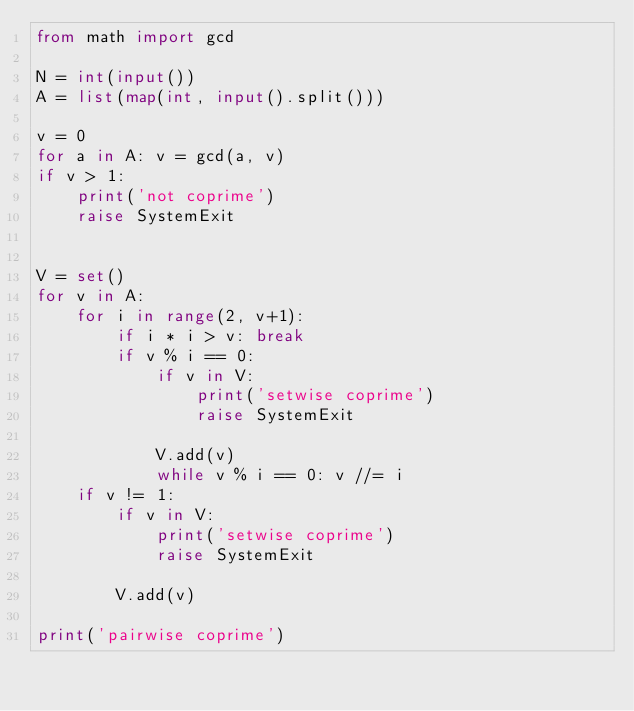Convert code to text. <code><loc_0><loc_0><loc_500><loc_500><_Python_>from math import gcd

N = int(input())
A = list(map(int, input().split()))

v = 0
for a in A: v = gcd(a, v)
if v > 1:
	print('not coprime')
	raise SystemExit


V = set()
for v in A:
	for i in range(2, v+1):
		if i * i > v: break
		if v % i == 0:
			if v in V:
				print('setwise coprime')
				raise SystemExit

			V.add(v)
			while v % i == 0: v //= i
	if v != 1:
		if v in V:
			print('setwise coprime')
			raise SystemExit

		V.add(v)

print('pairwise coprime')
</code> 